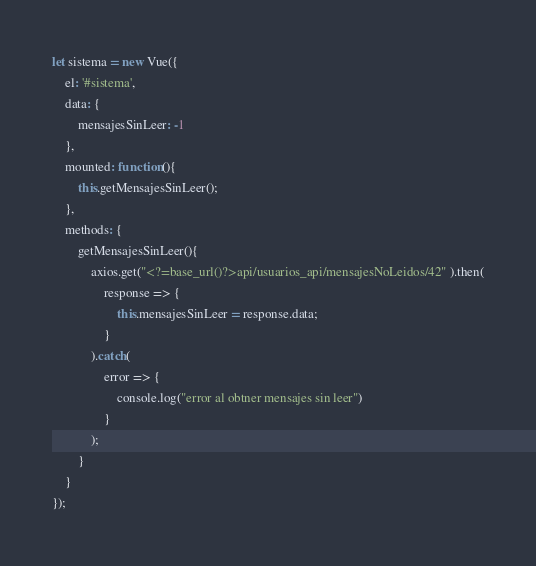<code> <loc_0><loc_0><loc_500><loc_500><_JavaScript_>

let sistema = new Vue({
    el: '#sistema',
    data: {
        mensajesSinLeer: -1
    },
    mounted: function(){
        this.getMensajesSinLeer();
    },
    methods: {
        getMensajesSinLeer(){
            axios.get("<?=base_url()?>api/usuarios_api/mensajesNoLeidos/42" ).then(
                response => {
                    this.mensajesSinLeer = response.data;
                }
            ).catch(
                error => {
                    console.log("error al obtner mensajes sin leer")
                }
            );
        }
    }
});</code> 